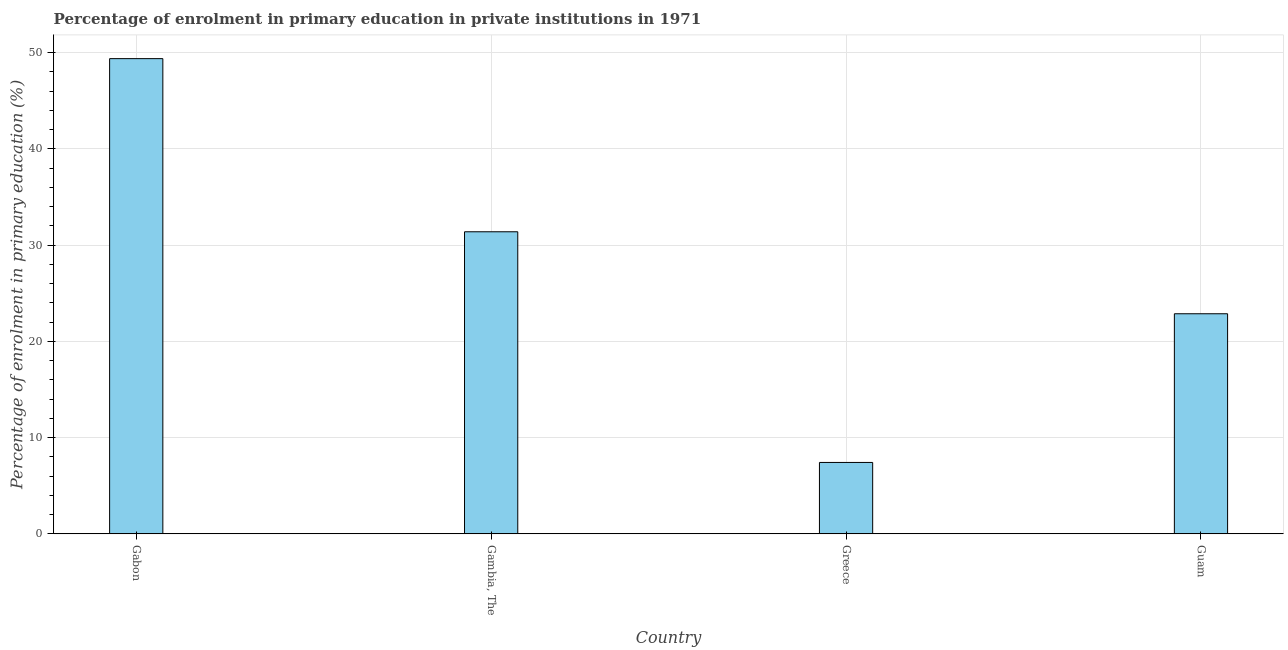Does the graph contain any zero values?
Offer a terse response. No. Does the graph contain grids?
Provide a succinct answer. Yes. What is the title of the graph?
Keep it short and to the point. Percentage of enrolment in primary education in private institutions in 1971. What is the label or title of the X-axis?
Your answer should be compact. Country. What is the label or title of the Y-axis?
Offer a very short reply. Percentage of enrolment in primary education (%). What is the enrolment percentage in primary education in Greece?
Give a very brief answer. 7.42. Across all countries, what is the maximum enrolment percentage in primary education?
Offer a very short reply. 49.38. Across all countries, what is the minimum enrolment percentage in primary education?
Offer a very short reply. 7.42. In which country was the enrolment percentage in primary education maximum?
Your response must be concise. Gabon. What is the sum of the enrolment percentage in primary education?
Offer a very short reply. 111.06. What is the difference between the enrolment percentage in primary education in Gambia, The and Greece?
Offer a terse response. 23.97. What is the average enrolment percentage in primary education per country?
Your answer should be very brief. 27.77. What is the median enrolment percentage in primary education?
Provide a short and direct response. 27.13. What is the ratio of the enrolment percentage in primary education in Gabon to that in Gambia, The?
Provide a short and direct response. 1.57. Is the enrolment percentage in primary education in Gabon less than that in Greece?
Ensure brevity in your answer.  No. Is the difference between the enrolment percentage in primary education in Gambia, The and Guam greater than the difference between any two countries?
Offer a very short reply. No. What is the difference between the highest and the second highest enrolment percentage in primary education?
Offer a very short reply. 17.99. Is the sum of the enrolment percentage in primary education in Gabon and Guam greater than the maximum enrolment percentage in primary education across all countries?
Keep it short and to the point. Yes. What is the difference between the highest and the lowest enrolment percentage in primary education?
Your response must be concise. 41.96. How many countries are there in the graph?
Your answer should be compact. 4. What is the difference between two consecutive major ticks on the Y-axis?
Your answer should be compact. 10. Are the values on the major ticks of Y-axis written in scientific E-notation?
Offer a very short reply. No. What is the Percentage of enrolment in primary education (%) in Gabon?
Make the answer very short. 49.38. What is the Percentage of enrolment in primary education (%) in Gambia, The?
Ensure brevity in your answer.  31.39. What is the Percentage of enrolment in primary education (%) in Greece?
Provide a short and direct response. 7.42. What is the Percentage of enrolment in primary education (%) of Guam?
Give a very brief answer. 22.87. What is the difference between the Percentage of enrolment in primary education (%) in Gabon and Gambia, The?
Offer a terse response. 17.99. What is the difference between the Percentage of enrolment in primary education (%) in Gabon and Greece?
Offer a terse response. 41.96. What is the difference between the Percentage of enrolment in primary education (%) in Gabon and Guam?
Your answer should be very brief. 26.51. What is the difference between the Percentage of enrolment in primary education (%) in Gambia, The and Greece?
Provide a short and direct response. 23.97. What is the difference between the Percentage of enrolment in primary education (%) in Gambia, The and Guam?
Keep it short and to the point. 8.52. What is the difference between the Percentage of enrolment in primary education (%) in Greece and Guam?
Ensure brevity in your answer.  -15.45. What is the ratio of the Percentage of enrolment in primary education (%) in Gabon to that in Gambia, The?
Your answer should be compact. 1.57. What is the ratio of the Percentage of enrolment in primary education (%) in Gabon to that in Greece?
Offer a terse response. 6.65. What is the ratio of the Percentage of enrolment in primary education (%) in Gabon to that in Guam?
Your answer should be compact. 2.16. What is the ratio of the Percentage of enrolment in primary education (%) in Gambia, The to that in Greece?
Keep it short and to the point. 4.23. What is the ratio of the Percentage of enrolment in primary education (%) in Gambia, The to that in Guam?
Offer a terse response. 1.37. What is the ratio of the Percentage of enrolment in primary education (%) in Greece to that in Guam?
Your answer should be very brief. 0.32. 